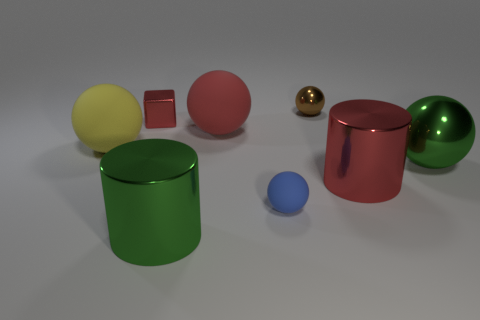Does the blue matte object have the same size as the red metallic cube that is to the left of the blue matte ball?
Ensure brevity in your answer.  Yes. There is a large green metal object that is to the left of the large metallic ball; what shape is it?
Provide a short and direct response. Cylinder. Are there any metal objects on the right side of the metallic cylinder that is in front of the tiny object in front of the big yellow rubber thing?
Provide a succinct answer. Yes. What is the material of the big red thing that is the same shape as the tiny blue thing?
Give a very brief answer. Rubber. How many blocks are tiny red metal objects or big green objects?
Your answer should be very brief. 1. There is a red rubber thing that is left of the small matte object; does it have the same size as the green thing that is to the right of the tiny brown metallic ball?
Offer a very short reply. Yes. What is the material of the tiny blue object in front of the large matte ball that is on the left side of the small red metallic block?
Provide a short and direct response. Rubber. Are there fewer tiny brown spheres to the left of the yellow rubber object than tiny purple metallic cylinders?
Ensure brevity in your answer.  No. What shape is the yellow thing that is made of the same material as the blue thing?
Your response must be concise. Sphere. What number of other things are there of the same shape as the tiny red metallic thing?
Provide a succinct answer. 0. 